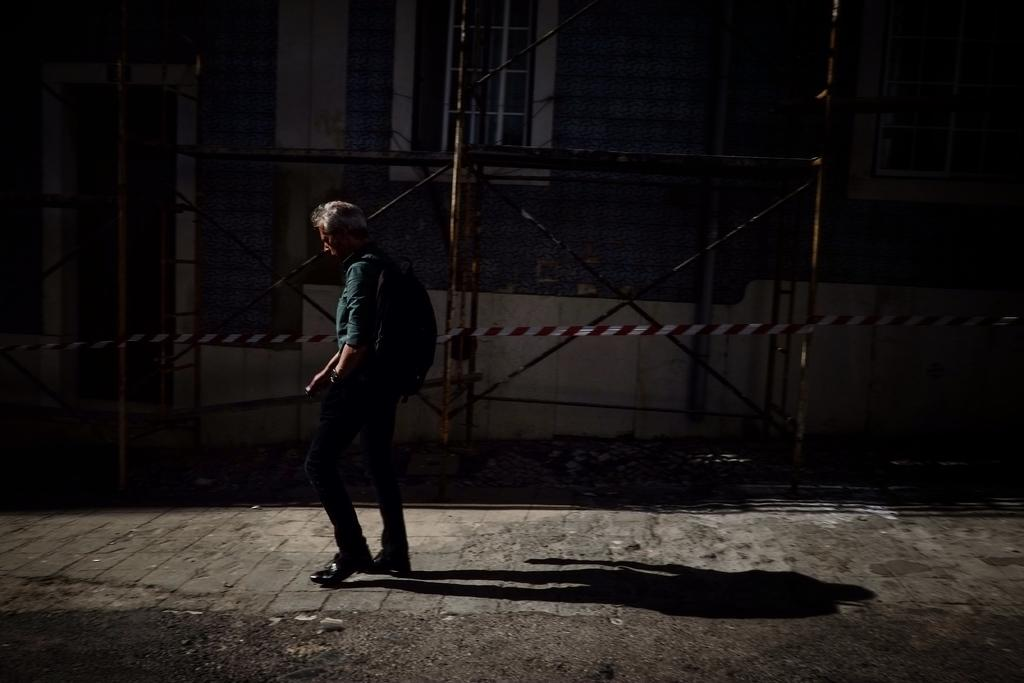What is happening in the foreground of the picture? There is a person walking in the foreground of the picture. What surface is the person walking on? The person is walking on a pavement. What can be seen in the background of the image? There are iron frames and at least one building in the background of the image. What type of flag is being waved by the queen in the image? There is no queen or flag present in the image. 